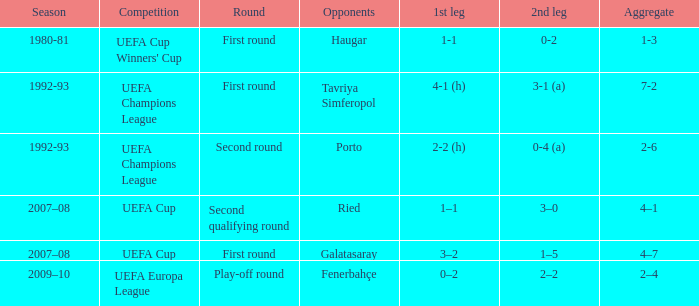What is the total number of round where opponents is haugar 1.0. 